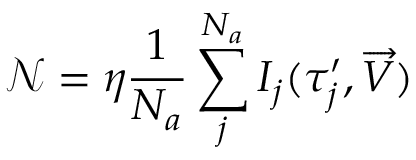Convert formula to latex. <formula><loc_0><loc_0><loc_500><loc_500>\ m a t h s c r { N } = \eta \frac { 1 } { N _ { a } } \sum _ { j } ^ { N _ { a } } I _ { j } ( { \tau } _ { j } ^ { \prime } , \overrightarrow { V } )</formula> 